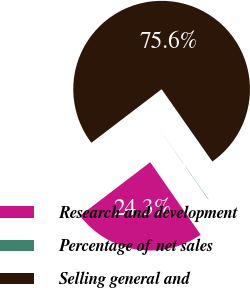Convert chart. <chart><loc_0><loc_0><loc_500><loc_500><pie_chart><fcel>Research and development<fcel>Percentage of net sales<fcel>Selling general and<nl><fcel>24.3%<fcel>0.06%<fcel>75.64%<nl></chart> 